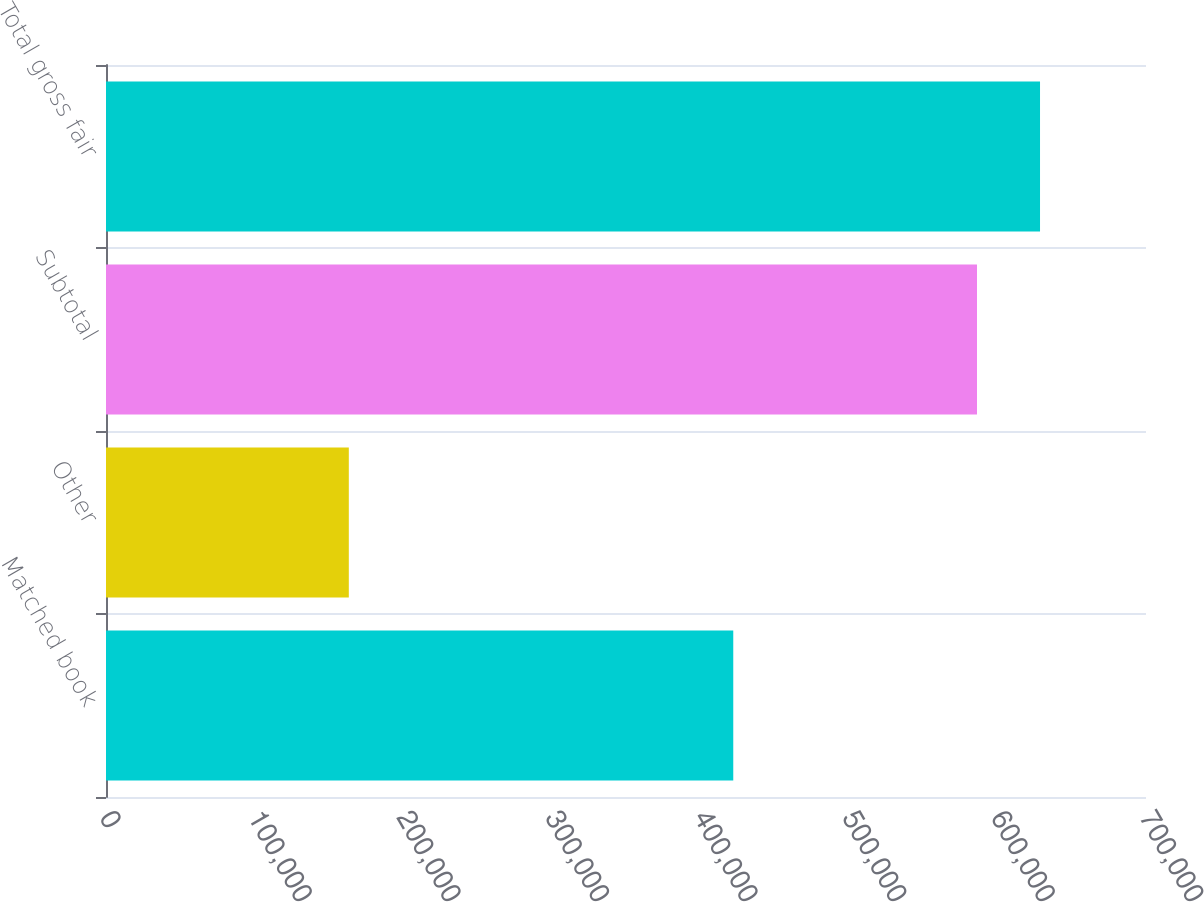Convert chart. <chart><loc_0><loc_0><loc_500><loc_500><bar_chart><fcel>Matched book<fcel>Other<fcel>Subtotal<fcel>Total gross fair<nl><fcel>422196<fcel>163433<fcel>586249<fcel>628670<nl></chart> 